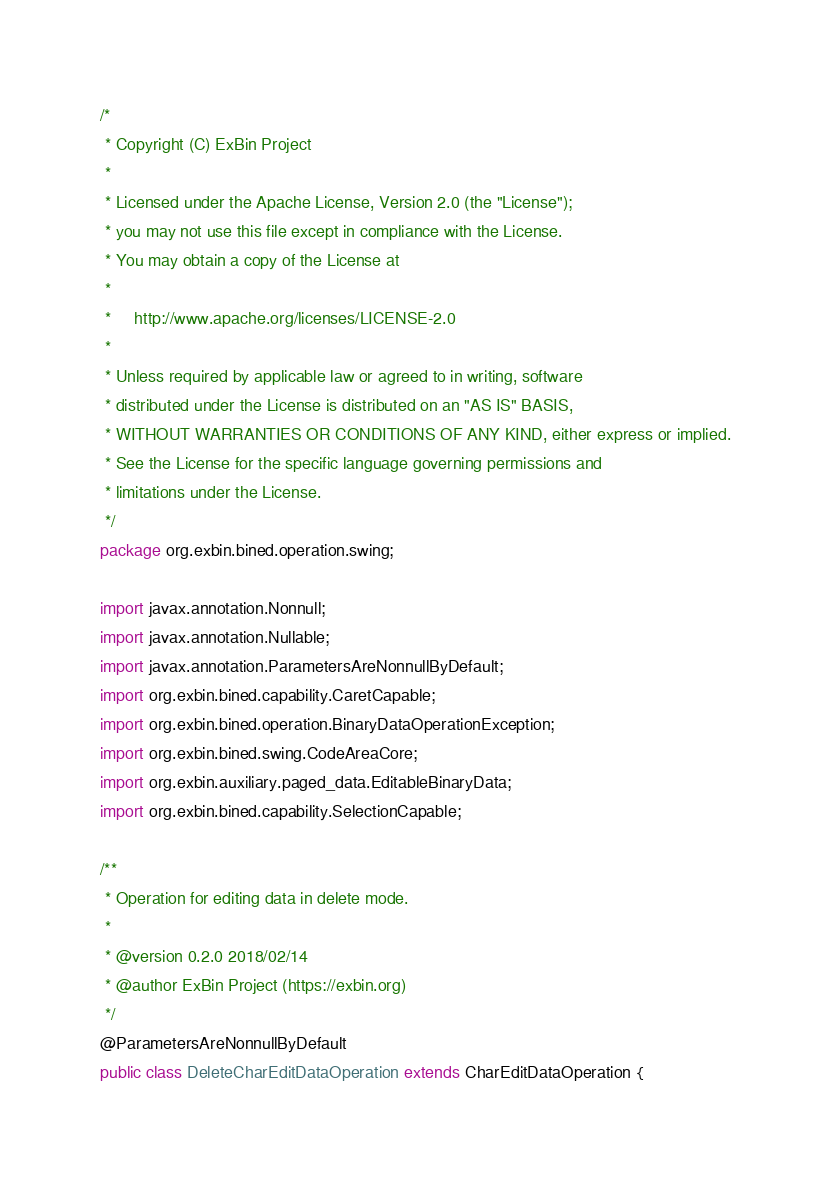Convert code to text. <code><loc_0><loc_0><loc_500><loc_500><_Java_>/*
 * Copyright (C) ExBin Project
 *
 * Licensed under the Apache License, Version 2.0 (the "License");
 * you may not use this file except in compliance with the License.
 * You may obtain a copy of the License at
 *
 *     http://www.apache.org/licenses/LICENSE-2.0
 *
 * Unless required by applicable law or agreed to in writing, software
 * distributed under the License is distributed on an "AS IS" BASIS,
 * WITHOUT WARRANTIES OR CONDITIONS OF ANY KIND, either express or implied.
 * See the License for the specific language governing permissions and
 * limitations under the License.
 */
package org.exbin.bined.operation.swing;

import javax.annotation.Nonnull;
import javax.annotation.Nullable;
import javax.annotation.ParametersAreNonnullByDefault;
import org.exbin.bined.capability.CaretCapable;
import org.exbin.bined.operation.BinaryDataOperationException;
import org.exbin.bined.swing.CodeAreaCore;
import org.exbin.auxiliary.paged_data.EditableBinaryData;
import org.exbin.bined.capability.SelectionCapable;

/**
 * Operation for editing data in delete mode.
 *
 * @version 0.2.0 2018/02/14
 * @author ExBin Project (https://exbin.org)
 */
@ParametersAreNonnullByDefault
public class DeleteCharEditDataOperation extends CharEditDataOperation {
</code> 